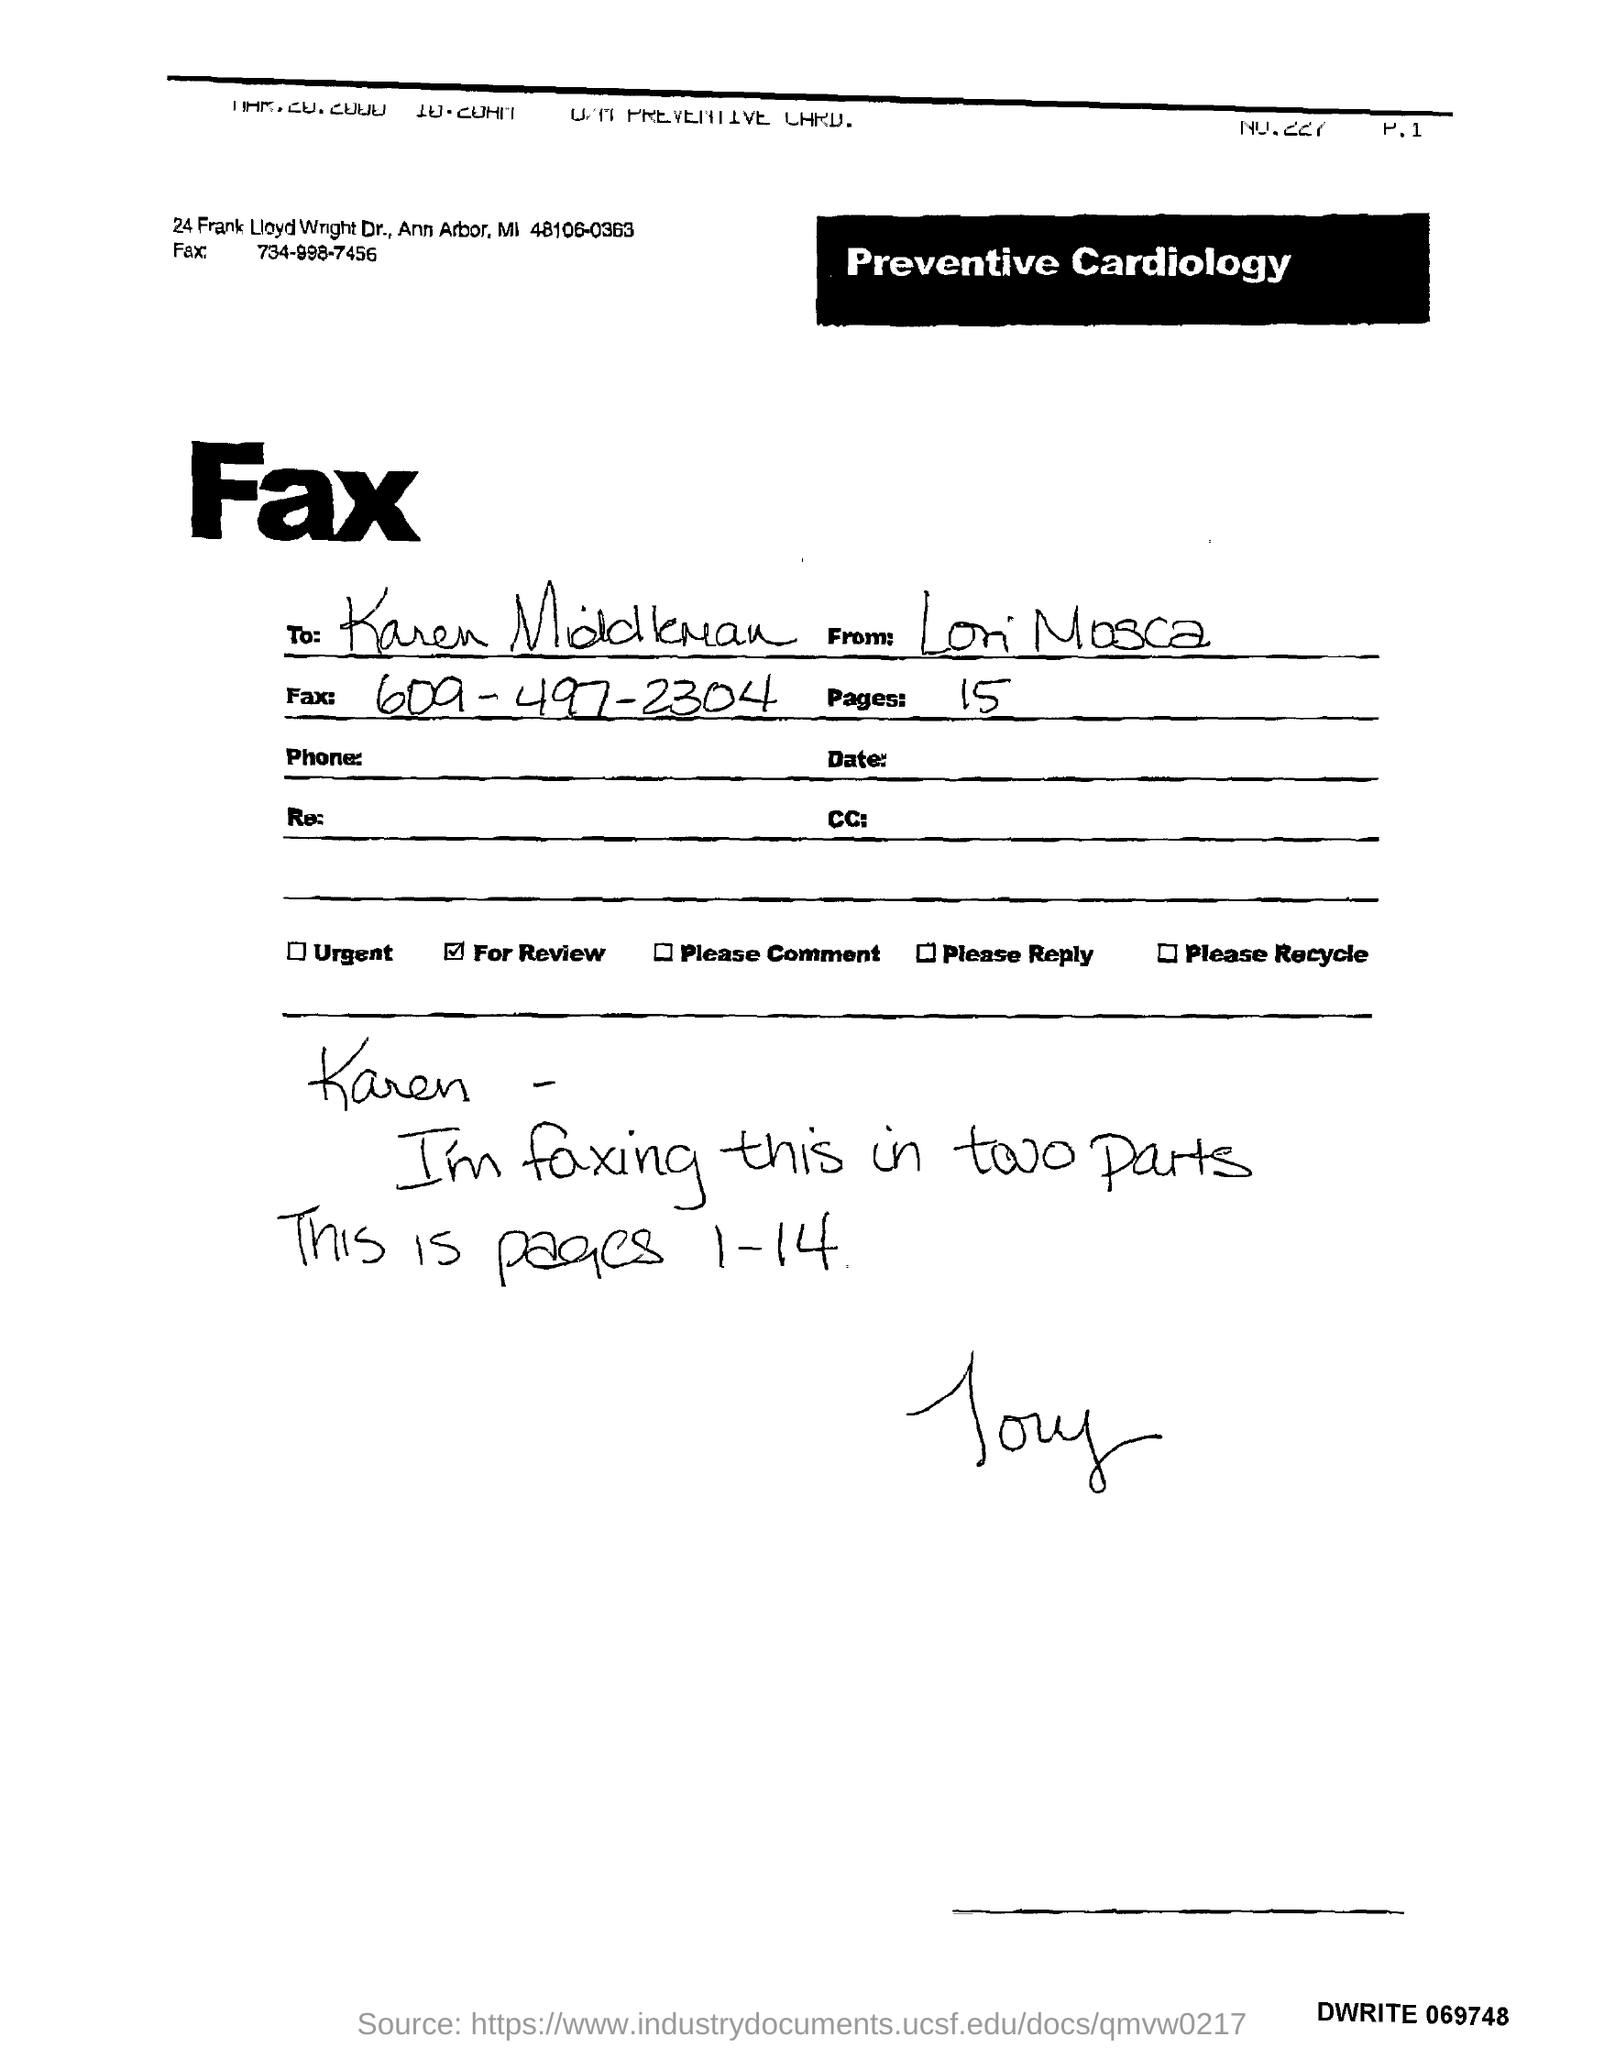Who is sender?
Your answer should be very brief. Lori Mosca. 